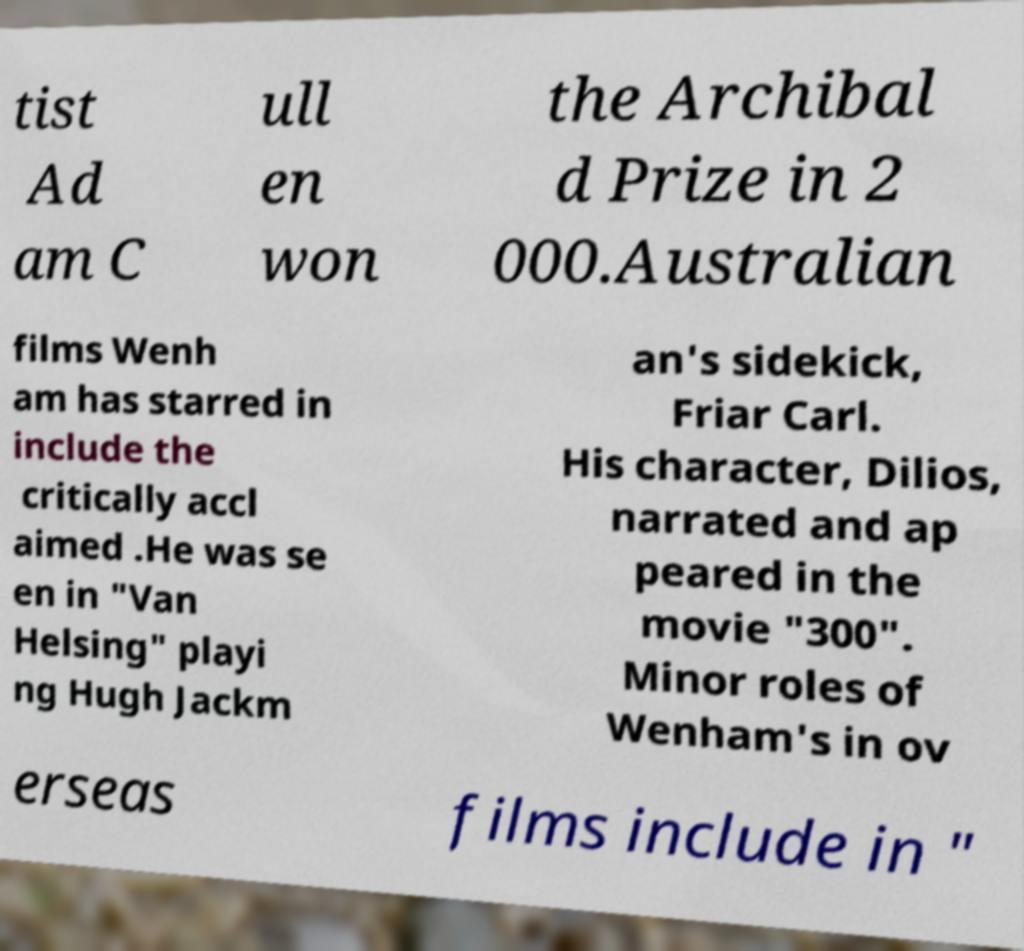I need the written content from this picture converted into text. Can you do that? tist Ad am C ull en won the Archibal d Prize in 2 000.Australian films Wenh am has starred in include the critically accl aimed .He was se en in "Van Helsing" playi ng Hugh Jackm an's sidekick, Friar Carl. His character, Dilios, narrated and ap peared in the movie "300". Minor roles of Wenham's in ov erseas films include in " 